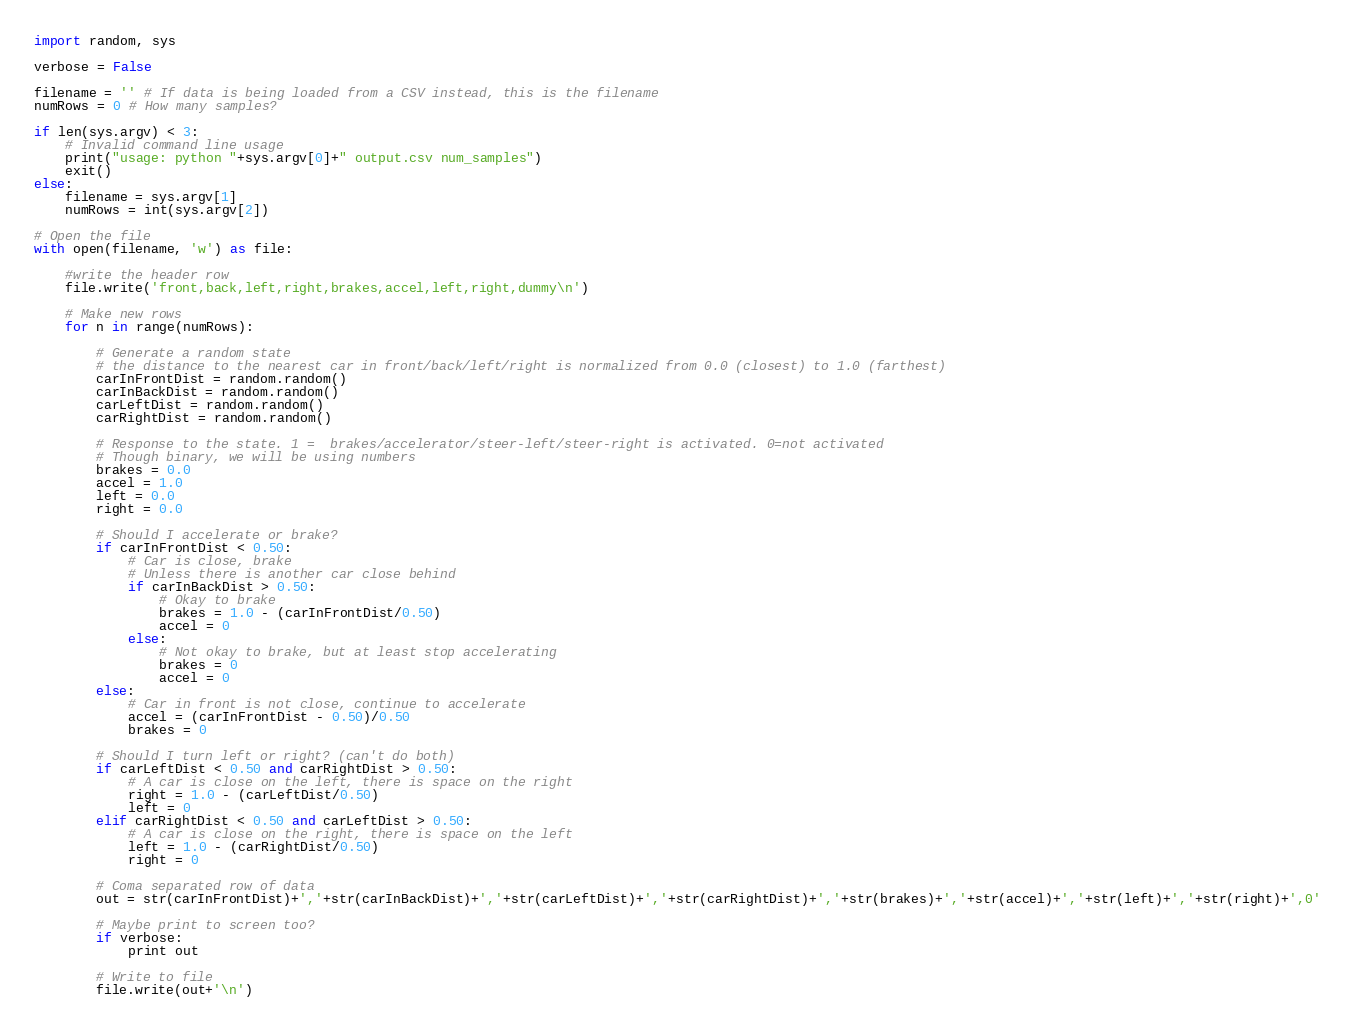Convert code to text. <code><loc_0><loc_0><loc_500><loc_500><_Python_>import random, sys

verbose = False

filename = '' # If data is being loaded from a CSV instead, this is the filename
numRows = 0 # How many samples?

if len(sys.argv) < 3:
	# Invalid command line usage
	print("usage: python "+sys.argv[0]+" output.csv num_samples")
	exit()
else:
	filename = sys.argv[1]
	numRows = int(sys.argv[2])

# Open the file
with open(filename, 'w') as file:

	#write the header row
	file.write('front,back,left,right,brakes,accel,left,right,dummy\n')
	
	# Make new rows
	for n in range(numRows):

		# Generate a random state
		# the distance to the nearest car in front/back/left/right is normalized from 0.0 (closest) to 1.0 (farthest)
		carInFrontDist = random.random()
		carInBackDist = random.random()
		carLeftDist = random.random()
		carRightDist = random.random()

		# Response to the state. 1 =  brakes/accelerator/steer-left/steer-right is activated. 0=not activated
		# Though binary, we will be using numbers
		brakes = 0.0
		accel = 1.0
		left = 0.0
		right = 0.0
		
		# Should I accelerate or brake?
		if carInFrontDist < 0.50:
			# Car is close, brake
			# Unless there is another car close behind
			if carInBackDist > 0.50:
				# Okay to brake
				brakes = 1.0 - (carInFrontDist/0.50)
				accel = 0
			else:
				# Not okay to brake, but at least stop accelerating
				brakes = 0
				accel = 0
		else:
			# Car in front is not close, continue to accelerate
			accel = (carInFrontDist - 0.50)/0.50
			brakes = 0
		
		# Should I turn left or right? (can't do both)
		if carLeftDist < 0.50 and carRightDist > 0.50:
			# A car is close on the left, there is space on the right
			right = 1.0 - (carLeftDist/0.50)
			left = 0
		elif carRightDist < 0.50 and carLeftDist > 0.50:
			# A car is close on the right, there is space on the left
			left = 1.0 - (carRightDist/0.50)
			right = 0
		
		# Coma separated row of data
		out = str(carInFrontDist)+','+str(carInBackDist)+','+str(carLeftDist)+','+str(carRightDist)+','+str(brakes)+','+str(accel)+','+str(left)+','+str(right)+',0'
		
		# Maybe print to screen too?
		if verbose:
			print out
		
		# Write to file
		file.write(out+'\n')

</code> 